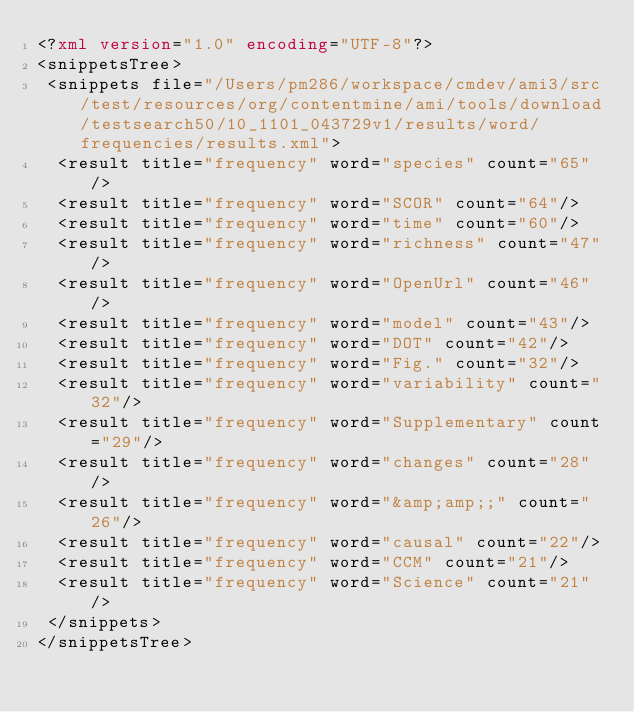Convert code to text. <code><loc_0><loc_0><loc_500><loc_500><_XML_><?xml version="1.0" encoding="UTF-8"?>
<snippetsTree>
 <snippets file="/Users/pm286/workspace/cmdev/ami3/src/test/resources/org/contentmine/ami/tools/download/testsearch50/10_1101_043729v1/results/word/frequencies/results.xml">
  <result title="frequency" word="species" count="65"/>
  <result title="frequency" word="SCOR" count="64"/>
  <result title="frequency" word="time" count="60"/>
  <result title="frequency" word="richness" count="47"/>
  <result title="frequency" word="OpenUrl" count="46"/>
  <result title="frequency" word="model" count="43"/>
  <result title="frequency" word="DOT" count="42"/>
  <result title="frequency" word="Fig." count="32"/>
  <result title="frequency" word="variability" count="32"/>
  <result title="frequency" word="Supplementary" count="29"/>
  <result title="frequency" word="changes" count="28"/>
  <result title="frequency" word="&amp;amp;;" count="26"/>
  <result title="frequency" word="causal" count="22"/>
  <result title="frequency" word="CCM" count="21"/>
  <result title="frequency" word="Science" count="21"/>
 </snippets>
</snippetsTree>
</code> 